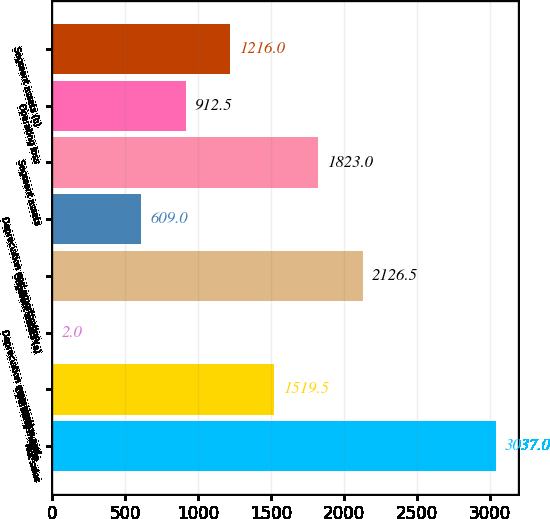<chart> <loc_0><loc_0><loc_500><loc_500><bar_chart><fcel>Net sales<fcel>Operating income<fcel>Depreciation amortization and<fcel>Segment assets (a)<fcel>Depreciation and amortization<fcel>Segment assets<fcel>Operating loss<fcel>Segment assets (b)<nl><fcel>3037<fcel>1519.5<fcel>2<fcel>2126.5<fcel>609<fcel>1823<fcel>912.5<fcel>1216<nl></chart> 